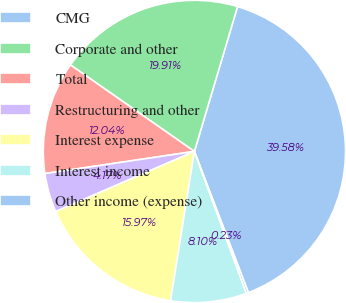Convert chart to OTSL. <chart><loc_0><loc_0><loc_500><loc_500><pie_chart><fcel>CMG<fcel>Corporate and other<fcel>Total<fcel>Restructuring and other<fcel>Interest expense<fcel>Interest income<fcel>Other income (expense)<nl><fcel>39.58%<fcel>19.91%<fcel>12.04%<fcel>4.17%<fcel>15.97%<fcel>8.1%<fcel>0.23%<nl></chart> 